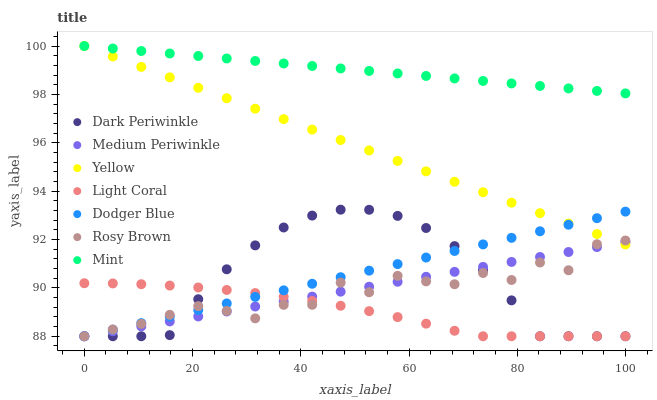Does Light Coral have the minimum area under the curve?
Answer yes or no. Yes. Does Mint have the maximum area under the curve?
Answer yes or no. Yes. Does Medium Periwinkle have the minimum area under the curve?
Answer yes or no. No. Does Medium Periwinkle have the maximum area under the curve?
Answer yes or no. No. Is Mint the smoothest?
Answer yes or no. Yes. Is Rosy Brown the roughest?
Answer yes or no. Yes. Is Medium Periwinkle the smoothest?
Answer yes or no. No. Is Medium Periwinkle the roughest?
Answer yes or no. No. Does Rosy Brown have the lowest value?
Answer yes or no. Yes. Does Yellow have the lowest value?
Answer yes or no. No. Does Mint have the highest value?
Answer yes or no. Yes. Does Medium Periwinkle have the highest value?
Answer yes or no. No. Is Dark Periwinkle less than Yellow?
Answer yes or no. Yes. Is Mint greater than Light Coral?
Answer yes or no. Yes. Does Yellow intersect Dodger Blue?
Answer yes or no. Yes. Is Yellow less than Dodger Blue?
Answer yes or no. No. Is Yellow greater than Dodger Blue?
Answer yes or no. No. Does Dark Periwinkle intersect Yellow?
Answer yes or no. No. 